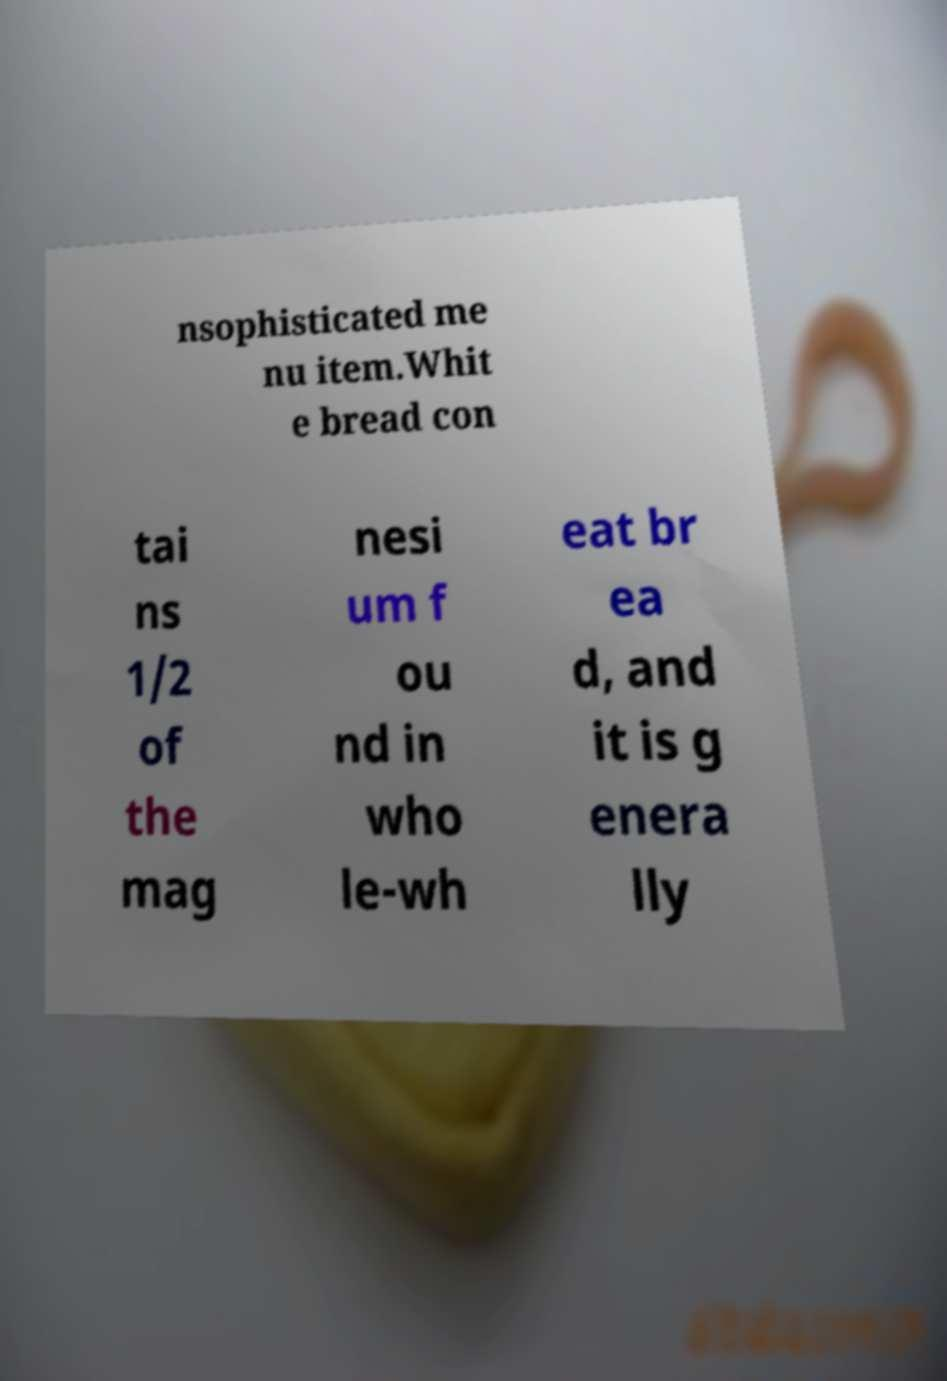Can you accurately transcribe the text from the provided image for me? nsophisticated me nu item.Whit e bread con tai ns 1/2 of the mag nesi um f ou nd in who le-wh eat br ea d, and it is g enera lly 